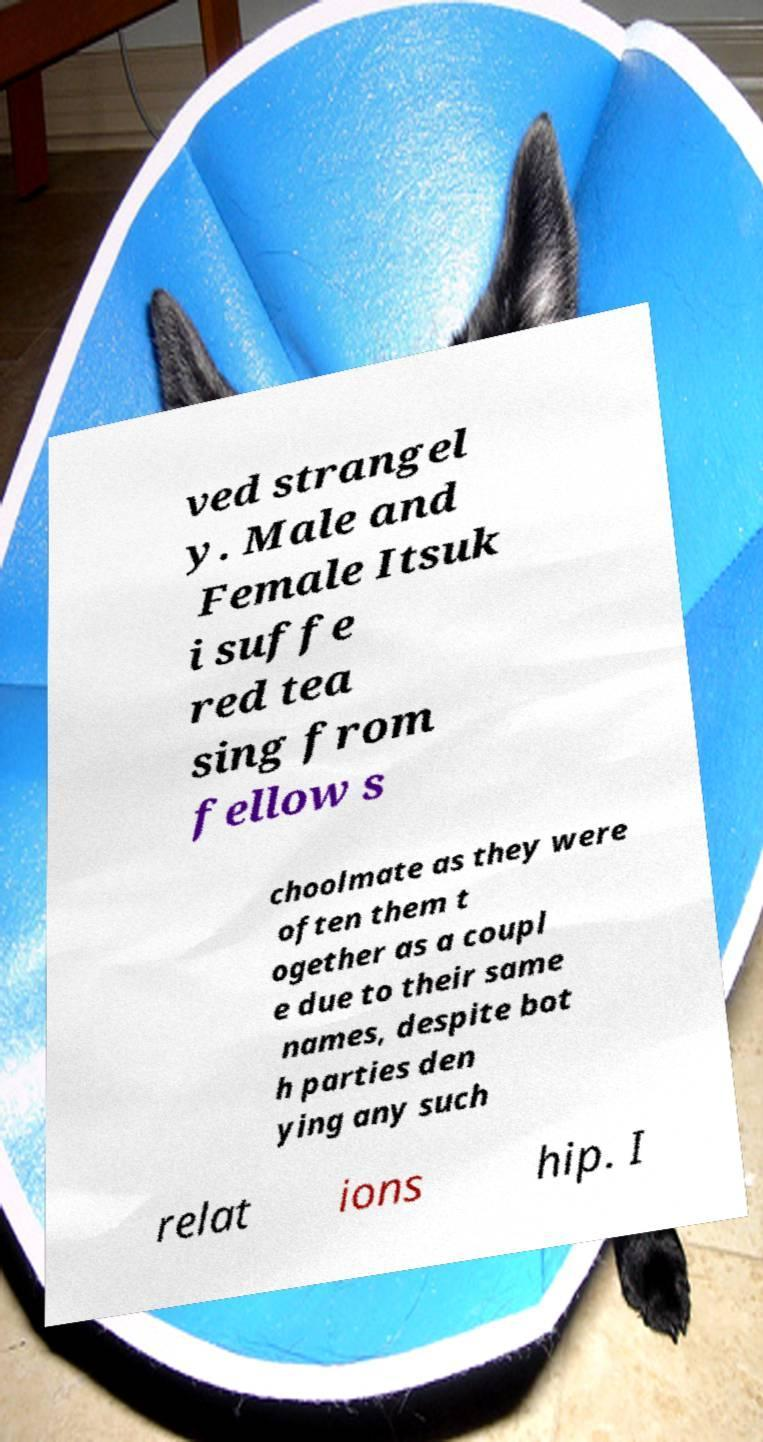There's text embedded in this image that I need extracted. Can you transcribe it verbatim? ved strangel y. Male and Female Itsuk i suffe red tea sing from fellow s choolmate as they were often them t ogether as a coupl e due to their same names, despite bot h parties den ying any such relat ions hip. I 